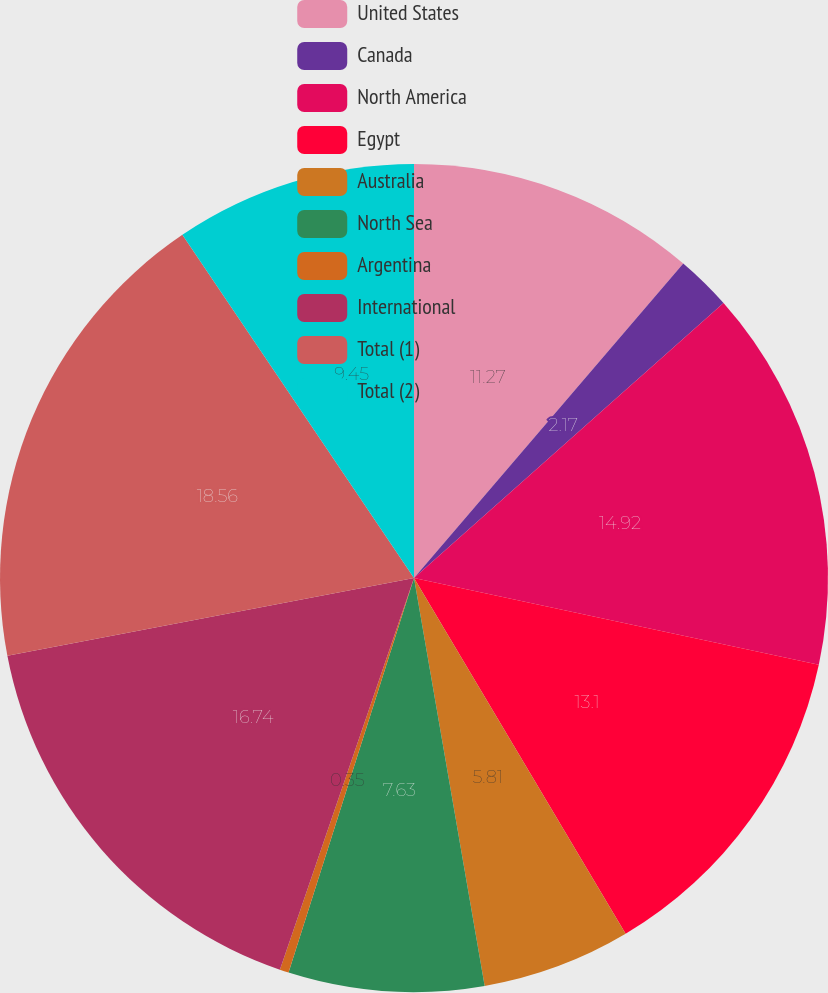Convert chart to OTSL. <chart><loc_0><loc_0><loc_500><loc_500><pie_chart><fcel>United States<fcel>Canada<fcel>North America<fcel>Egypt<fcel>Australia<fcel>North Sea<fcel>Argentina<fcel>International<fcel>Total (1)<fcel>Total (2)<nl><fcel>11.27%<fcel>2.17%<fcel>14.92%<fcel>13.1%<fcel>5.81%<fcel>7.63%<fcel>0.35%<fcel>16.74%<fcel>18.56%<fcel>9.45%<nl></chart> 